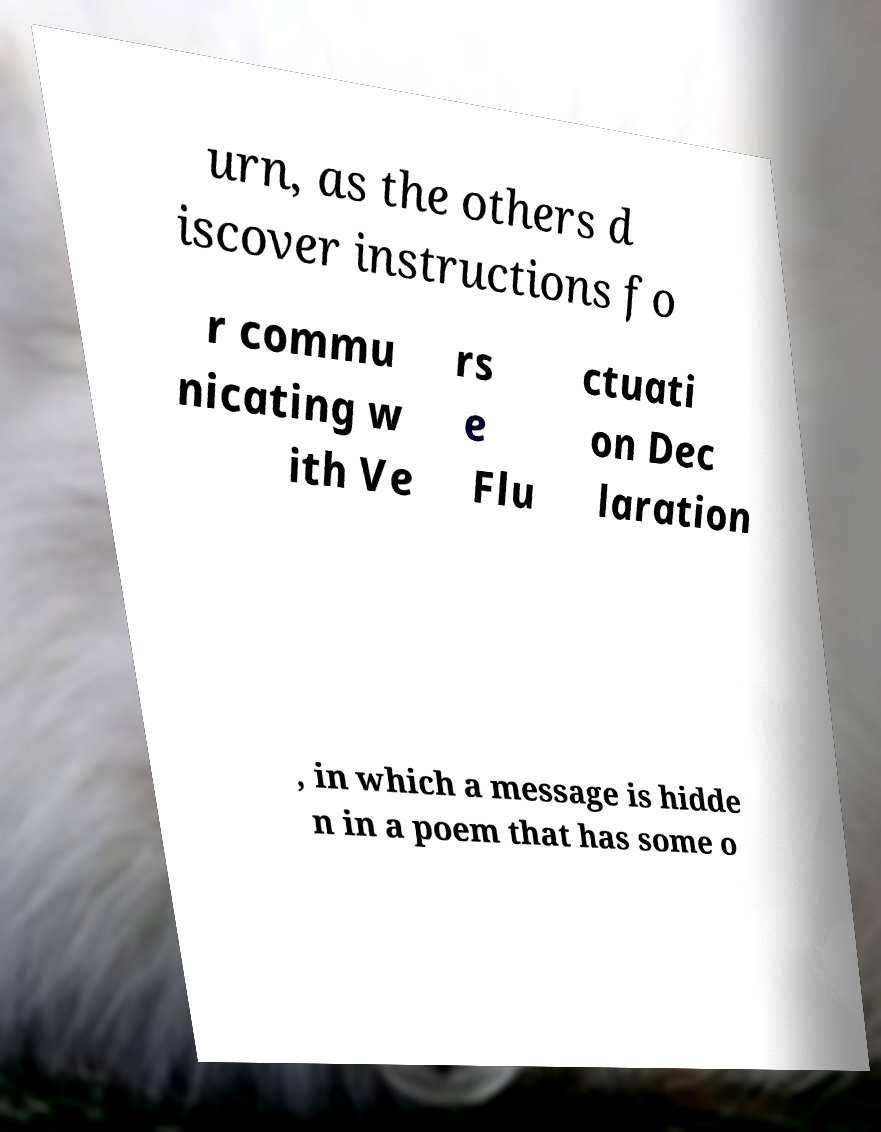There's text embedded in this image that I need extracted. Can you transcribe it verbatim? urn, as the others d iscover instructions fo r commu nicating w ith Ve rs e Flu ctuati on Dec laration , in which a message is hidde n in a poem that has some o 